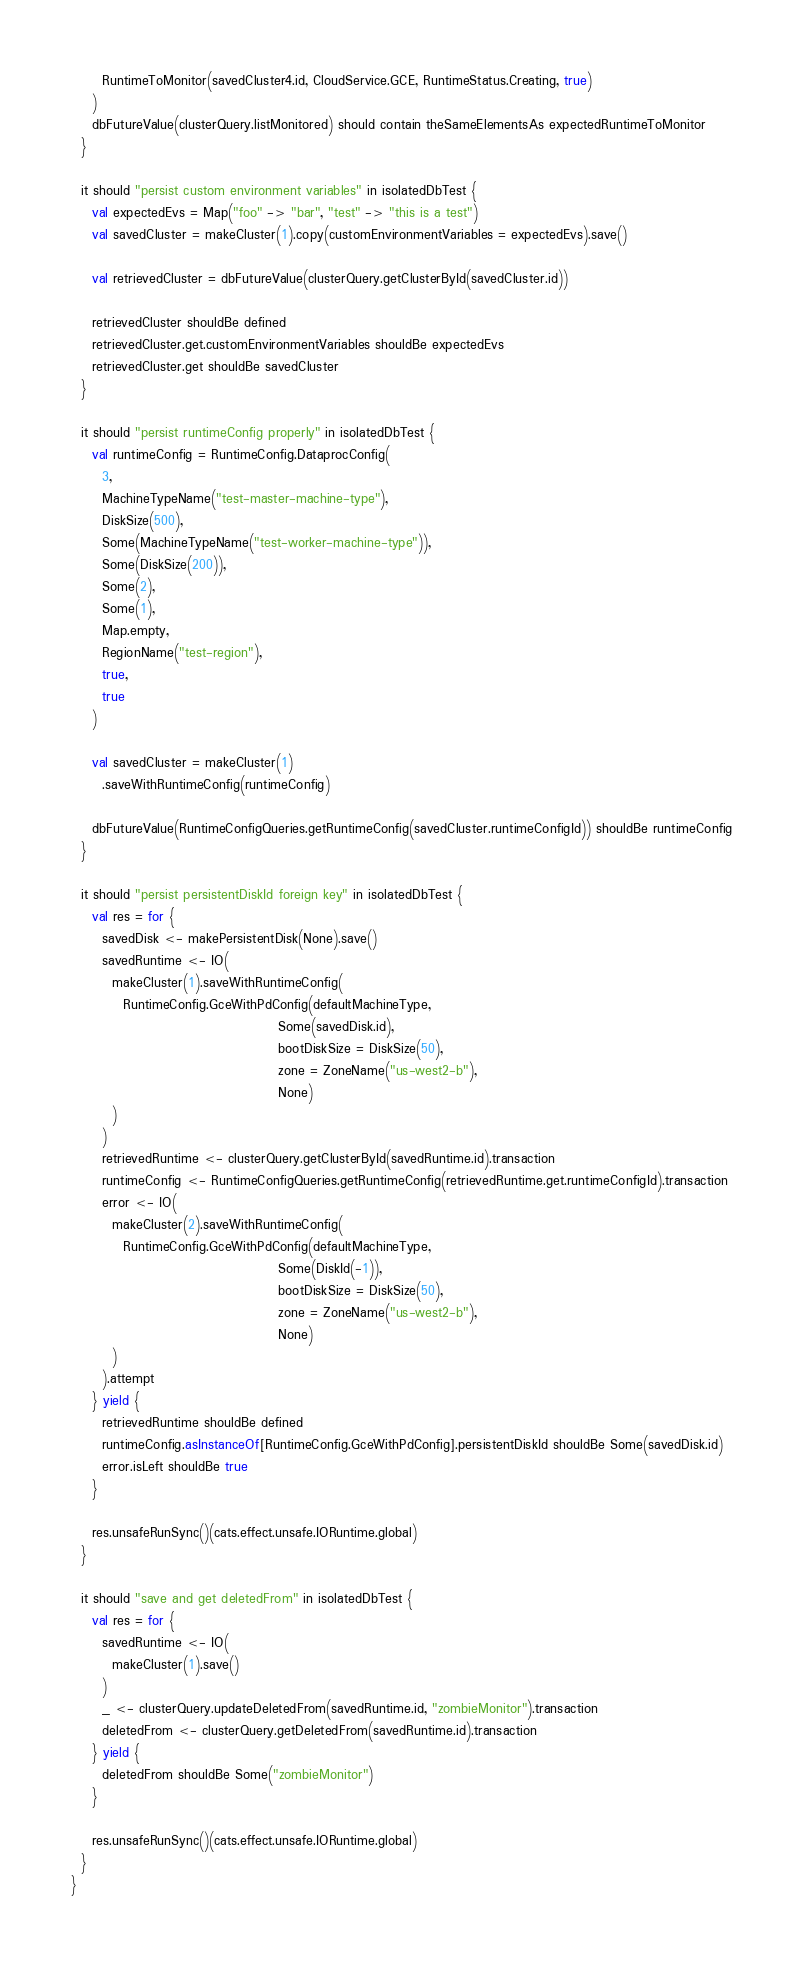Convert code to text. <code><loc_0><loc_0><loc_500><loc_500><_Scala_>      RuntimeToMonitor(savedCluster4.id, CloudService.GCE, RuntimeStatus.Creating, true)
    )
    dbFutureValue(clusterQuery.listMonitored) should contain theSameElementsAs expectedRuntimeToMonitor
  }

  it should "persist custom environment variables" in isolatedDbTest {
    val expectedEvs = Map("foo" -> "bar", "test" -> "this is a test")
    val savedCluster = makeCluster(1).copy(customEnvironmentVariables = expectedEvs).save()

    val retrievedCluster = dbFutureValue(clusterQuery.getClusterById(savedCluster.id))

    retrievedCluster shouldBe defined
    retrievedCluster.get.customEnvironmentVariables shouldBe expectedEvs
    retrievedCluster.get shouldBe savedCluster
  }

  it should "persist runtimeConfig properly" in isolatedDbTest {
    val runtimeConfig = RuntimeConfig.DataprocConfig(
      3,
      MachineTypeName("test-master-machine-type"),
      DiskSize(500),
      Some(MachineTypeName("test-worker-machine-type")),
      Some(DiskSize(200)),
      Some(2),
      Some(1),
      Map.empty,
      RegionName("test-region"),
      true,
      true
    )

    val savedCluster = makeCluster(1)
      .saveWithRuntimeConfig(runtimeConfig)

    dbFutureValue(RuntimeConfigQueries.getRuntimeConfig(savedCluster.runtimeConfigId)) shouldBe runtimeConfig
  }

  it should "persist persistentDiskId foreign key" in isolatedDbTest {
    val res = for {
      savedDisk <- makePersistentDisk(None).save()
      savedRuntime <- IO(
        makeCluster(1).saveWithRuntimeConfig(
          RuntimeConfig.GceWithPdConfig(defaultMachineType,
                                        Some(savedDisk.id),
                                        bootDiskSize = DiskSize(50),
                                        zone = ZoneName("us-west2-b"),
                                        None)
        )
      )
      retrievedRuntime <- clusterQuery.getClusterById(savedRuntime.id).transaction
      runtimeConfig <- RuntimeConfigQueries.getRuntimeConfig(retrievedRuntime.get.runtimeConfigId).transaction
      error <- IO(
        makeCluster(2).saveWithRuntimeConfig(
          RuntimeConfig.GceWithPdConfig(defaultMachineType,
                                        Some(DiskId(-1)),
                                        bootDiskSize = DiskSize(50),
                                        zone = ZoneName("us-west2-b"),
                                        None)
        )
      ).attempt
    } yield {
      retrievedRuntime shouldBe defined
      runtimeConfig.asInstanceOf[RuntimeConfig.GceWithPdConfig].persistentDiskId shouldBe Some(savedDisk.id)
      error.isLeft shouldBe true
    }

    res.unsafeRunSync()(cats.effect.unsafe.IORuntime.global)
  }

  it should "save and get deletedFrom" in isolatedDbTest {
    val res = for {
      savedRuntime <- IO(
        makeCluster(1).save()
      )
      _ <- clusterQuery.updateDeletedFrom(savedRuntime.id, "zombieMonitor").transaction
      deletedFrom <- clusterQuery.getDeletedFrom(savedRuntime.id).transaction
    } yield {
      deletedFrom shouldBe Some("zombieMonitor")
    }

    res.unsafeRunSync()(cats.effect.unsafe.IORuntime.global)
  }
}
</code> 